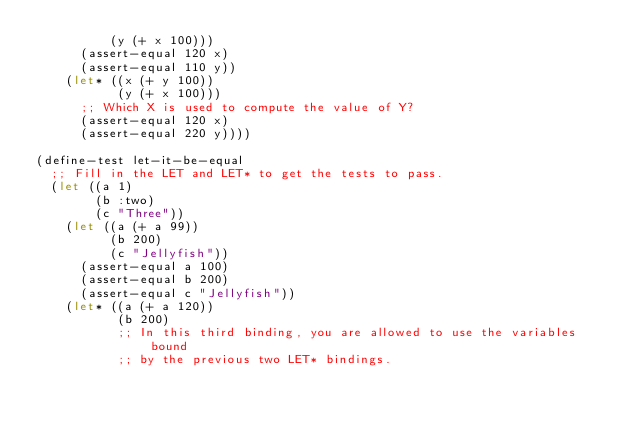Convert code to text. <code><loc_0><loc_0><loc_500><loc_500><_Lisp_>          (y (+ x 100)))
      (assert-equal 120 x)
      (assert-equal 110 y))
    (let* ((x (+ y 100))
           (y (+ x 100)))
      ;; Which X is used to compute the value of Y?
      (assert-equal 120 x)
      (assert-equal 220 y))))

(define-test let-it-be-equal
  ;; Fill in the LET and LET* to get the tests to pass.
  (let ((a 1)
        (b :two)
        (c "Three"))
    (let ((a (+ a 99))
          (b 200)
          (c "Jellyfish"))
      (assert-equal a 100)
      (assert-equal b 200)
      (assert-equal c "Jellyfish"))
    (let* ((a (+ a 120))
           (b 200)
           ;; In this third binding, you are allowed to use the variables bound
           ;; by the previous two LET* bindings.</code> 